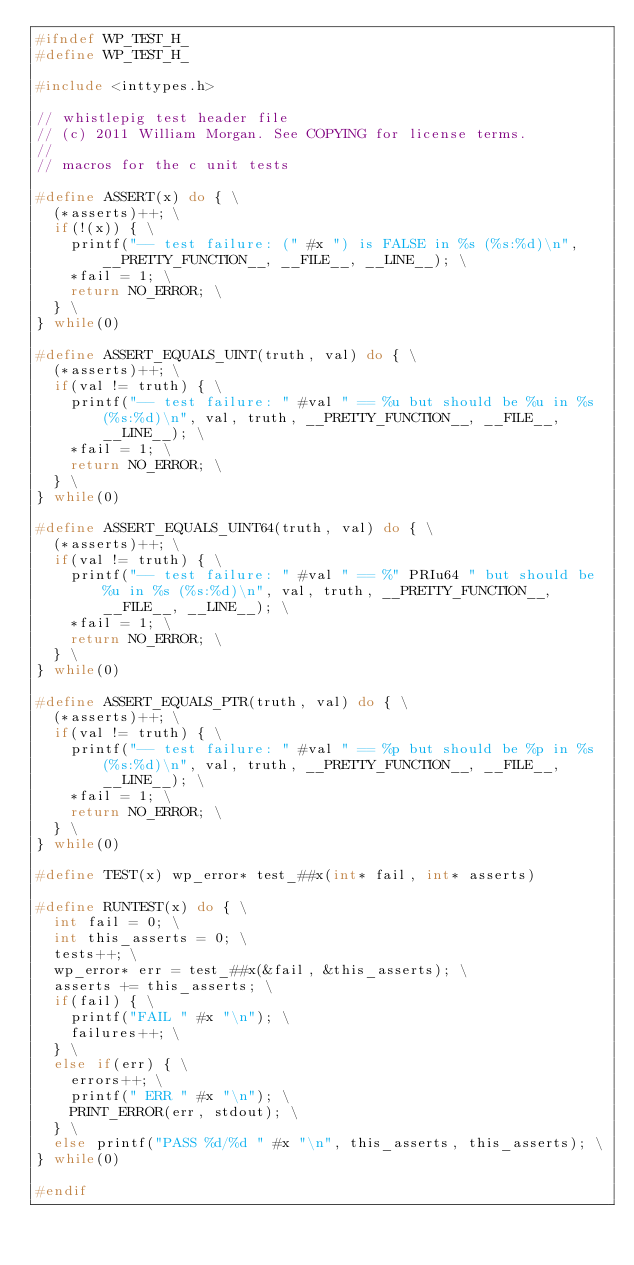<code> <loc_0><loc_0><loc_500><loc_500><_C_>#ifndef WP_TEST_H_
#define WP_TEST_H_

#include <inttypes.h>

// whistlepig test header file
// (c) 2011 William Morgan. See COPYING for license terms.
//
// macros for the c unit tests

#define ASSERT(x) do { \
  (*asserts)++; \
  if(!(x)) { \
    printf("-- test failure: (" #x ") is FALSE in %s (%s:%d)\n", __PRETTY_FUNCTION__, __FILE__, __LINE__); \
    *fail = 1; \
    return NO_ERROR; \
  } \
} while(0)

#define ASSERT_EQUALS_UINT(truth, val) do { \
  (*asserts)++; \
  if(val != truth) { \
    printf("-- test failure: " #val " == %u but should be %u in %s (%s:%d)\n", val, truth, __PRETTY_FUNCTION__, __FILE__, __LINE__); \
    *fail = 1; \
    return NO_ERROR; \
  } \
} while(0)

#define ASSERT_EQUALS_UINT64(truth, val) do { \
  (*asserts)++; \
  if(val != truth) { \
    printf("-- test failure: " #val " == %" PRIu64 " but should be %u in %s (%s:%d)\n", val, truth, __PRETTY_FUNCTION__, __FILE__, __LINE__); \
    *fail = 1; \
    return NO_ERROR; \
  } \
} while(0)

#define ASSERT_EQUALS_PTR(truth, val) do { \
  (*asserts)++; \
  if(val != truth) { \
    printf("-- test failure: " #val " == %p but should be %p in %s (%s:%d)\n", val, truth, __PRETTY_FUNCTION__, __FILE__, __LINE__); \
    *fail = 1; \
    return NO_ERROR; \
  } \
} while(0)

#define TEST(x) wp_error* test_##x(int* fail, int* asserts)

#define RUNTEST(x) do { \
  int fail = 0; \
  int this_asserts = 0; \
  tests++; \
  wp_error* err = test_##x(&fail, &this_asserts); \
  asserts += this_asserts; \
  if(fail) { \
    printf("FAIL " #x "\n"); \
    failures++; \
  } \
  else if(err) { \
    errors++; \
    printf(" ERR " #x "\n"); \
    PRINT_ERROR(err, stdout); \
  } \
  else printf("PASS %d/%d " #x "\n", this_asserts, this_asserts); \
} while(0)

#endif
</code> 